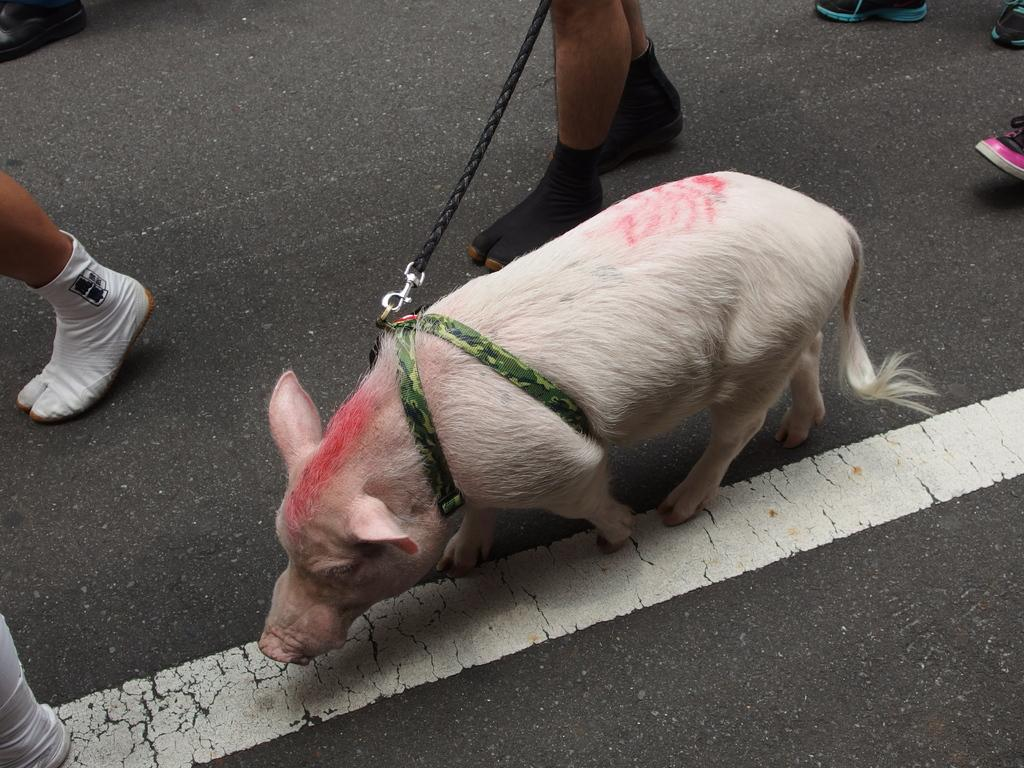What animal is present in the image? There is a pig in the image. How is the pig restrained in the image? The pig is tied with a chain. Are there any people in the image? Yes, there are people around the pig. What type of zipper can be seen on the pig's back in the image? There is no zipper present on the pig's back in the image. 